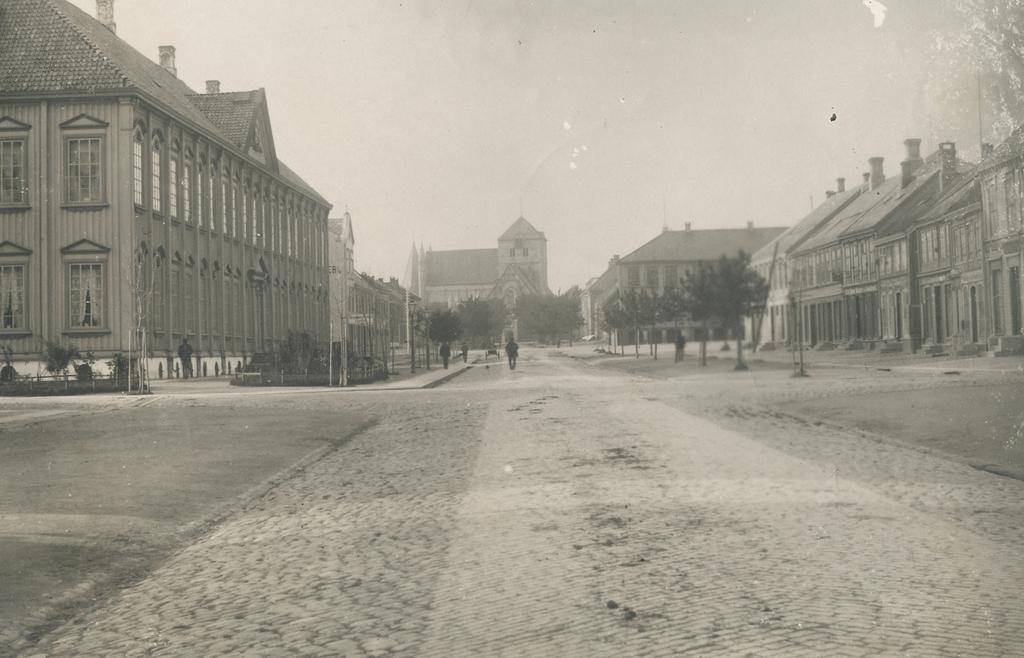In one or two sentences, can you explain what this image depicts? There is a black and white image. In this image, there is an outside view. There are some buildings and trees in the middle of the image. There is a sky at the top of the image. 